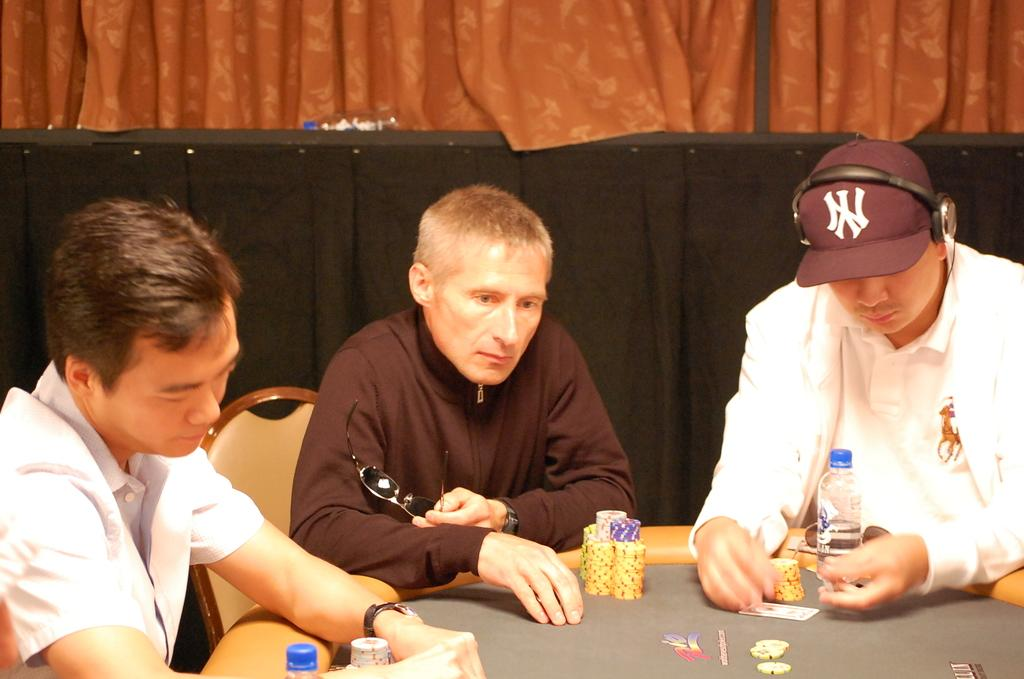How many people are in the image? There are three persons in the image. What are the persons doing in the image? The persons are sitting in chairs. Where are the chairs located in relation to the table? The chairs are near a table. What items can be seen on the table? There are casino coins, cards, and a bottle on the table. What is visible in the background of the image? There is a curtain in the background of the image. What type of finger can be seen holding the hose in the image? There is no finger or hose present in the image. How many trains are visible in the image? There are no trains visible in the image. 